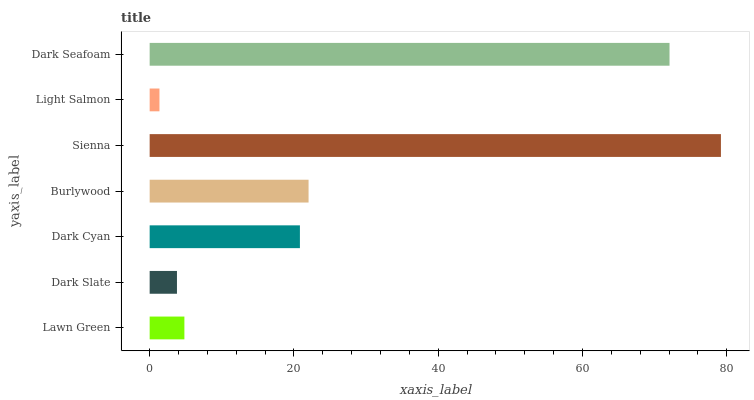Is Light Salmon the minimum?
Answer yes or no. Yes. Is Sienna the maximum?
Answer yes or no. Yes. Is Dark Slate the minimum?
Answer yes or no. No. Is Dark Slate the maximum?
Answer yes or no. No. Is Lawn Green greater than Dark Slate?
Answer yes or no. Yes. Is Dark Slate less than Lawn Green?
Answer yes or no. Yes. Is Dark Slate greater than Lawn Green?
Answer yes or no. No. Is Lawn Green less than Dark Slate?
Answer yes or no. No. Is Dark Cyan the high median?
Answer yes or no. Yes. Is Dark Cyan the low median?
Answer yes or no. Yes. Is Dark Seafoam the high median?
Answer yes or no. No. Is Dark Seafoam the low median?
Answer yes or no. No. 